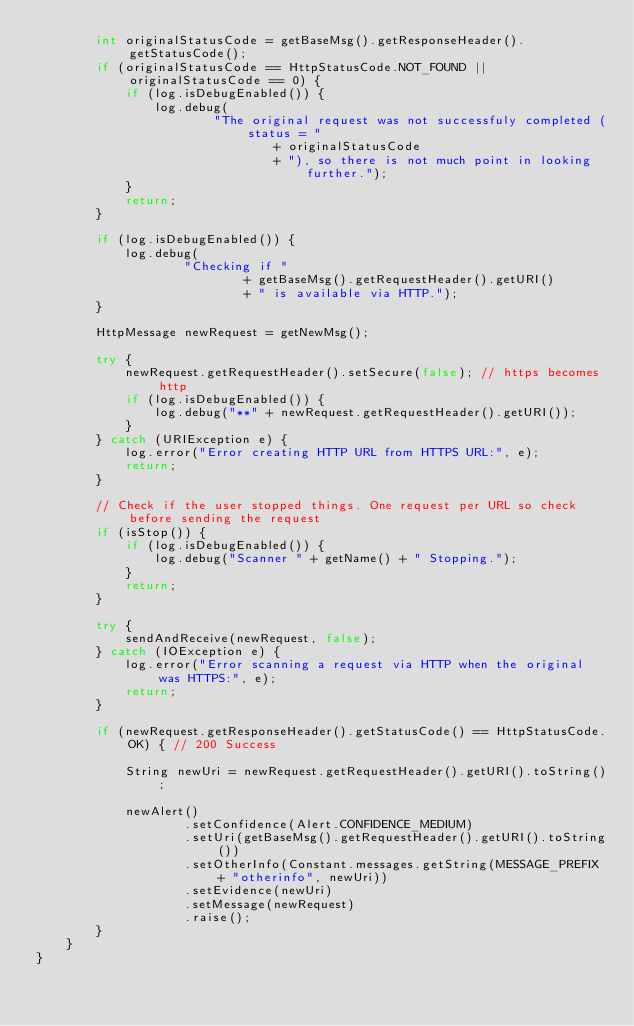Convert code to text. <code><loc_0><loc_0><loc_500><loc_500><_Java_>        int originalStatusCode = getBaseMsg().getResponseHeader().getStatusCode();
        if (originalStatusCode == HttpStatusCode.NOT_FOUND || originalStatusCode == 0) {
            if (log.isDebugEnabled()) {
                log.debug(
                        "The original request was not successfuly completed (status = "
                                + originalStatusCode
                                + "), so there is not much point in looking further.");
            }
            return;
        }

        if (log.isDebugEnabled()) {
            log.debug(
                    "Checking if "
                            + getBaseMsg().getRequestHeader().getURI()
                            + " is available via HTTP.");
        }

        HttpMessage newRequest = getNewMsg();

        try {
            newRequest.getRequestHeader().setSecure(false); // https becomes http
            if (log.isDebugEnabled()) {
                log.debug("**" + newRequest.getRequestHeader().getURI());
            }
        } catch (URIException e) {
            log.error("Error creating HTTP URL from HTTPS URL:", e);
            return;
        }

        // Check if the user stopped things. One request per URL so check before sending the request
        if (isStop()) {
            if (log.isDebugEnabled()) {
                log.debug("Scanner " + getName() + " Stopping.");
            }
            return;
        }

        try {
            sendAndReceive(newRequest, false);
        } catch (IOException e) {
            log.error("Error scanning a request via HTTP when the original was HTTPS:", e);
            return;
        }

        if (newRequest.getResponseHeader().getStatusCode() == HttpStatusCode.OK) { // 200 Success

            String newUri = newRequest.getRequestHeader().getURI().toString();

            newAlert()
                    .setConfidence(Alert.CONFIDENCE_MEDIUM)
                    .setUri(getBaseMsg().getRequestHeader().getURI().toString())
                    .setOtherInfo(Constant.messages.getString(MESSAGE_PREFIX + "otherinfo", newUri))
                    .setEvidence(newUri)
                    .setMessage(newRequest)
                    .raise();
        }
    }
}
</code> 